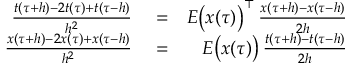<formula> <loc_0><loc_0><loc_500><loc_500>\begin{array} { r l r } { \frac { t ( \tau + h ) - 2 t ( \tau ) + t ( \tau - h ) } { h ^ { 2 } } } & = } & { E \left ( x ( \tau ) \right ) ^ { \top } \, \frac { x ( \tau + h ) - x ( \tau - h ) } { 2 h } } \\ { \frac { x ( \tau + h ) - 2 x ( \tau ) + x ( \tau - h ) } { h ^ { 2 } } } & = } & { E \left ( x ( \tau ) \right ) \, \frac { t ( \tau + h ) - t ( \tau - h ) } { 2 h } } \end{array}</formula> 